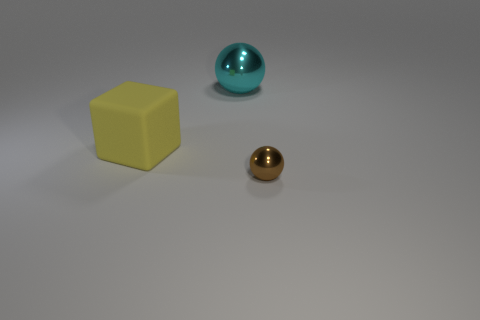What could be the materials of these objects? Based on their appearance, the yellow cube may be made of a plastic or matte-painted wood, the golden sphere looks metallic, and the larger turquoise sphere seems to have a reflective, possibly glass or polished metal surface. How can you guess the materials? The guesses are based on the visual cues, such as the matte finish of the yellow cube which is typical for plastic or painted wood, the shiny reflective quality of the gold sphere that is characteristic of metal surfaces, and the smooth reflection on the turquoise sphere suggesting a glass-like or metallic polish. 